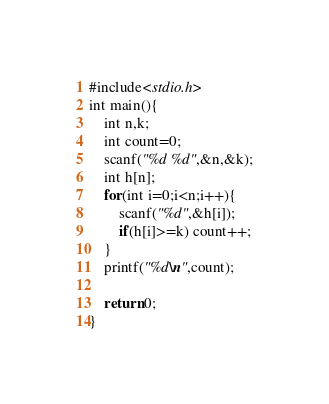Convert code to text. <code><loc_0><loc_0><loc_500><loc_500><_C_>#include<stdio.h>
int main(){
    int n,k;
    int count=0;
    scanf("%d %d",&n,&k);
    int h[n];
    for(int i=0;i<n;i++){
        scanf("%d",&h[i]);
        if(h[i]>=k) count++;
    }
    printf("%d\n",count);

    return 0;
}</code> 